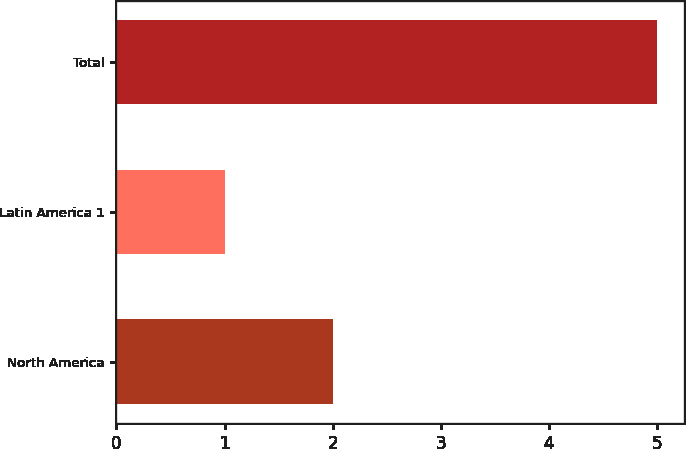Convert chart. <chart><loc_0><loc_0><loc_500><loc_500><bar_chart><fcel>North America<fcel>Latin America 1<fcel>Total<nl><fcel>2<fcel>1<fcel>5<nl></chart> 